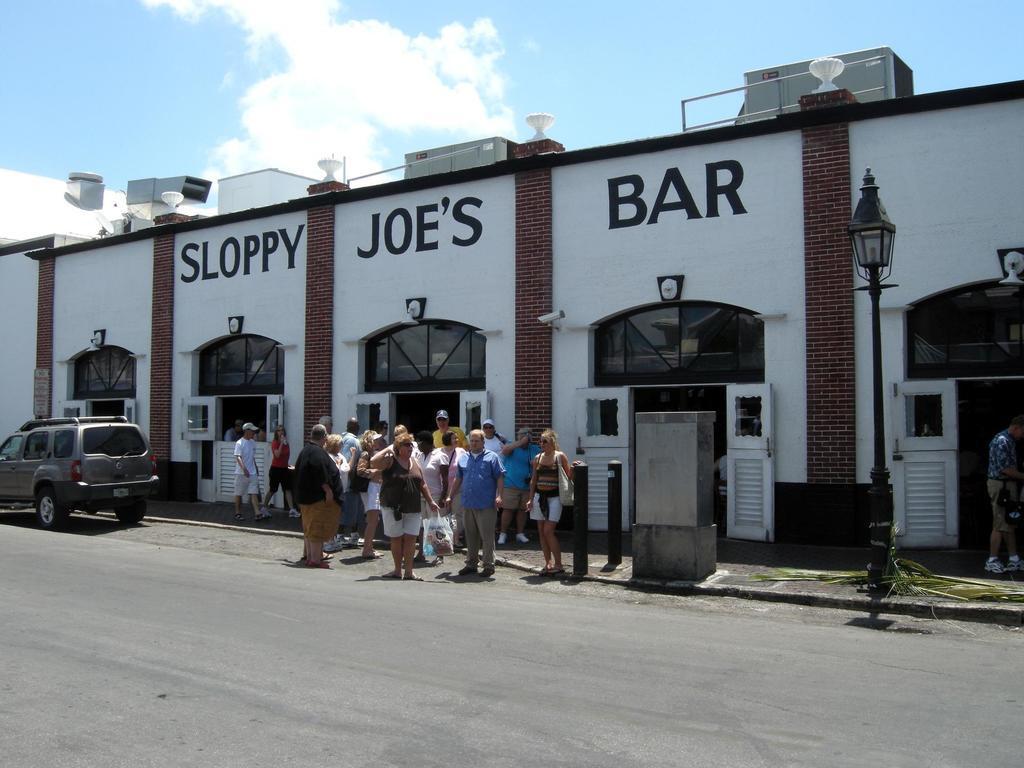Please provide a concise description of this image. As we can see in the image there are buildings, doors, street lamp, few people here and there, sky and clouds. 